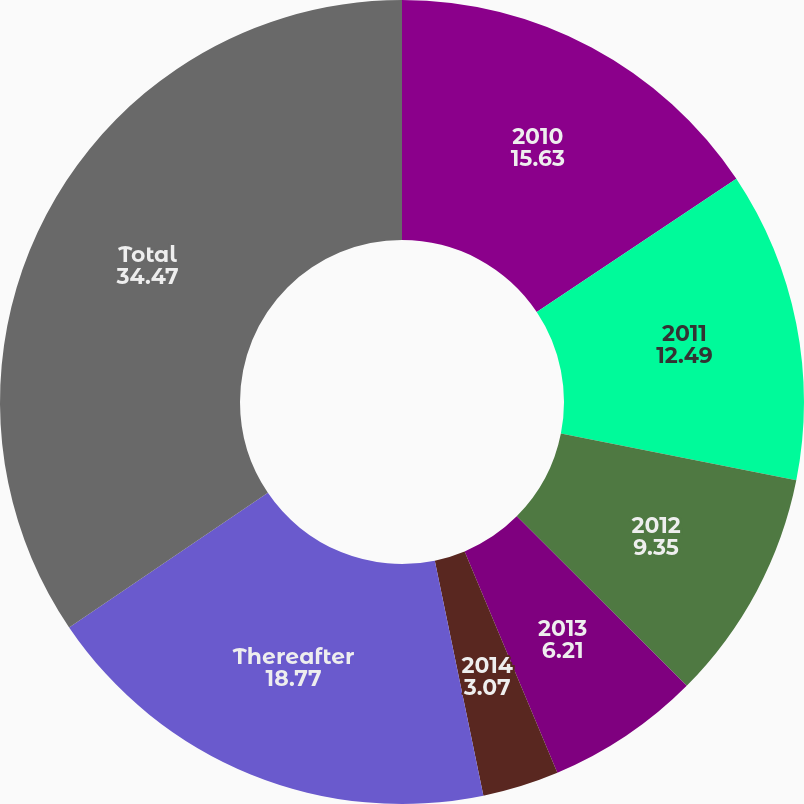Convert chart. <chart><loc_0><loc_0><loc_500><loc_500><pie_chart><fcel>2010<fcel>2011<fcel>2012<fcel>2013<fcel>2014<fcel>Thereafter<fcel>Total<nl><fcel>15.63%<fcel>12.49%<fcel>9.35%<fcel>6.21%<fcel>3.07%<fcel>18.77%<fcel>34.47%<nl></chart> 